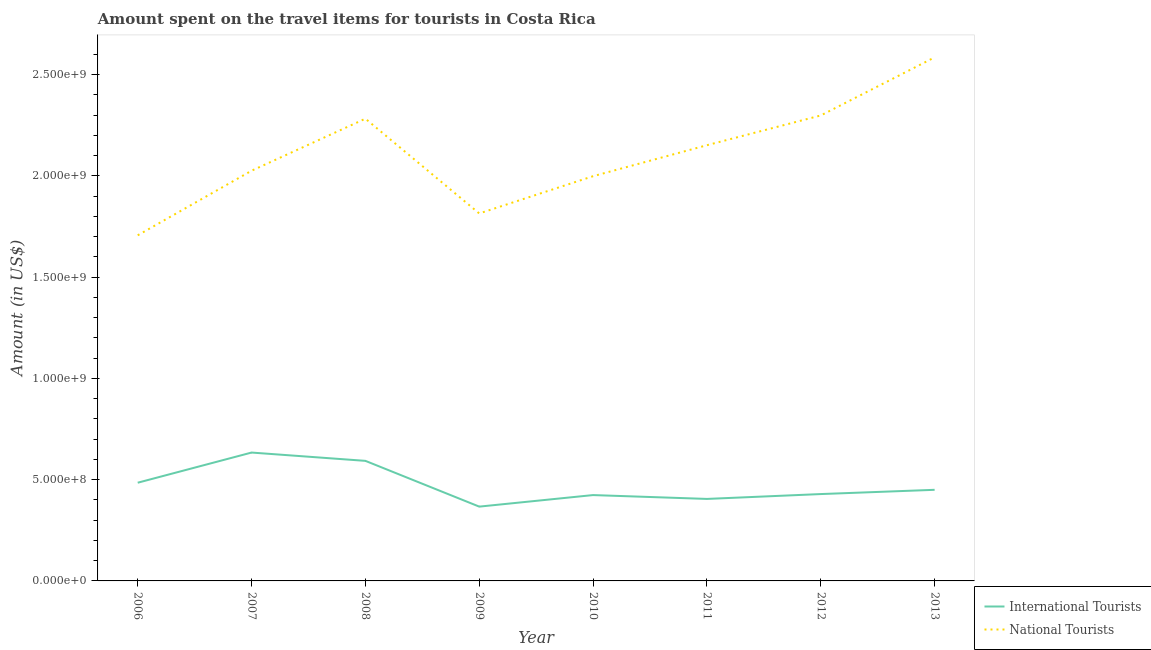How many different coloured lines are there?
Offer a very short reply. 2. Does the line corresponding to amount spent on travel items of international tourists intersect with the line corresponding to amount spent on travel items of national tourists?
Your answer should be very brief. No. What is the amount spent on travel items of international tourists in 2007?
Give a very brief answer. 6.34e+08. Across all years, what is the maximum amount spent on travel items of national tourists?
Provide a succinct answer. 2.59e+09. Across all years, what is the minimum amount spent on travel items of national tourists?
Your answer should be very brief. 1.71e+09. What is the total amount spent on travel items of international tourists in the graph?
Offer a terse response. 3.79e+09. What is the difference between the amount spent on travel items of national tourists in 2011 and that in 2013?
Your response must be concise. -4.34e+08. What is the difference between the amount spent on travel items of national tourists in 2006 and the amount spent on travel items of international tourists in 2009?
Give a very brief answer. 1.34e+09. What is the average amount spent on travel items of international tourists per year?
Your response must be concise. 4.73e+08. In the year 2012, what is the difference between the amount spent on travel items of international tourists and amount spent on travel items of national tourists?
Your response must be concise. -1.87e+09. What is the ratio of the amount spent on travel items of national tourists in 2007 to that in 2013?
Ensure brevity in your answer.  0.78. Is the amount spent on travel items of national tourists in 2008 less than that in 2010?
Make the answer very short. No. What is the difference between the highest and the second highest amount spent on travel items of international tourists?
Provide a short and direct response. 4.10e+07. What is the difference between the highest and the lowest amount spent on travel items of national tourists?
Your answer should be compact. 8.79e+08. In how many years, is the amount spent on travel items of international tourists greater than the average amount spent on travel items of international tourists taken over all years?
Your answer should be very brief. 3. Is the sum of the amount spent on travel items of national tourists in 2008 and 2012 greater than the maximum amount spent on travel items of international tourists across all years?
Offer a very short reply. Yes. Does the amount spent on travel items of international tourists monotonically increase over the years?
Your answer should be compact. No. Is the amount spent on travel items of national tourists strictly less than the amount spent on travel items of international tourists over the years?
Make the answer very short. No. How many lines are there?
Give a very brief answer. 2. How many years are there in the graph?
Offer a very short reply. 8. What is the difference between two consecutive major ticks on the Y-axis?
Your response must be concise. 5.00e+08. Does the graph contain any zero values?
Provide a succinct answer. No. Does the graph contain grids?
Your answer should be compact. No. Where does the legend appear in the graph?
Provide a short and direct response. Bottom right. What is the title of the graph?
Provide a succinct answer. Amount spent on the travel items for tourists in Costa Rica. Does "Mobile cellular" appear as one of the legend labels in the graph?
Keep it short and to the point. No. What is the label or title of the X-axis?
Make the answer very short. Year. What is the label or title of the Y-axis?
Your answer should be very brief. Amount (in US$). What is the Amount (in US$) in International Tourists in 2006?
Provide a succinct answer. 4.85e+08. What is the Amount (in US$) of National Tourists in 2006?
Ensure brevity in your answer.  1.71e+09. What is the Amount (in US$) of International Tourists in 2007?
Offer a terse response. 6.34e+08. What is the Amount (in US$) of National Tourists in 2007?
Provide a short and direct response. 2.03e+09. What is the Amount (in US$) in International Tourists in 2008?
Make the answer very short. 5.93e+08. What is the Amount (in US$) of National Tourists in 2008?
Offer a very short reply. 2.28e+09. What is the Amount (in US$) of International Tourists in 2009?
Give a very brief answer. 3.67e+08. What is the Amount (in US$) in National Tourists in 2009?
Provide a short and direct response. 1.82e+09. What is the Amount (in US$) in International Tourists in 2010?
Offer a very short reply. 4.24e+08. What is the Amount (in US$) of National Tourists in 2010?
Your answer should be very brief. 2.00e+09. What is the Amount (in US$) in International Tourists in 2011?
Give a very brief answer. 4.05e+08. What is the Amount (in US$) in National Tourists in 2011?
Offer a terse response. 2.15e+09. What is the Amount (in US$) in International Tourists in 2012?
Keep it short and to the point. 4.29e+08. What is the Amount (in US$) in National Tourists in 2012?
Provide a short and direct response. 2.30e+09. What is the Amount (in US$) of International Tourists in 2013?
Ensure brevity in your answer.  4.50e+08. What is the Amount (in US$) of National Tourists in 2013?
Ensure brevity in your answer.  2.59e+09. Across all years, what is the maximum Amount (in US$) of International Tourists?
Offer a terse response. 6.34e+08. Across all years, what is the maximum Amount (in US$) of National Tourists?
Give a very brief answer. 2.59e+09. Across all years, what is the minimum Amount (in US$) in International Tourists?
Your answer should be compact. 3.67e+08. Across all years, what is the minimum Amount (in US$) in National Tourists?
Offer a terse response. 1.71e+09. What is the total Amount (in US$) in International Tourists in the graph?
Ensure brevity in your answer.  3.79e+09. What is the total Amount (in US$) in National Tourists in the graph?
Give a very brief answer. 1.69e+1. What is the difference between the Amount (in US$) in International Tourists in 2006 and that in 2007?
Offer a very short reply. -1.49e+08. What is the difference between the Amount (in US$) in National Tourists in 2006 and that in 2007?
Give a very brief answer. -3.19e+08. What is the difference between the Amount (in US$) of International Tourists in 2006 and that in 2008?
Make the answer very short. -1.08e+08. What is the difference between the Amount (in US$) in National Tourists in 2006 and that in 2008?
Provide a short and direct response. -5.76e+08. What is the difference between the Amount (in US$) of International Tourists in 2006 and that in 2009?
Make the answer very short. 1.18e+08. What is the difference between the Amount (in US$) of National Tourists in 2006 and that in 2009?
Offer a terse response. -1.08e+08. What is the difference between the Amount (in US$) in International Tourists in 2006 and that in 2010?
Provide a succinct answer. 6.10e+07. What is the difference between the Amount (in US$) of National Tourists in 2006 and that in 2010?
Offer a very short reply. -2.92e+08. What is the difference between the Amount (in US$) in International Tourists in 2006 and that in 2011?
Keep it short and to the point. 8.00e+07. What is the difference between the Amount (in US$) of National Tourists in 2006 and that in 2011?
Your answer should be very brief. -4.45e+08. What is the difference between the Amount (in US$) of International Tourists in 2006 and that in 2012?
Keep it short and to the point. 5.60e+07. What is the difference between the Amount (in US$) in National Tourists in 2006 and that in 2012?
Give a very brief answer. -5.92e+08. What is the difference between the Amount (in US$) of International Tourists in 2006 and that in 2013?
Offer a terse response. 3.50e+07. What is the difference between the Amount (in US$) in National Tourists in 2006 and that in 2013?
Your answer should be compact. -8.79e+08. What is the difference between the Amount (in US$) of International Tourists in 2007 and that in 2008?
Your answer should be very brief. 4.10e+07. What is the difference between the Amount (in US$) in National Tourists in 2007 and that in 2008?
Ensure brevity in your answer.  -2.57e+08. What is the difference between the Amount (in US$) in International Tourists in 2007 and that in 2009?
Offer a terse response. 2.67e+08. What is the difference between the Amount (in US$) in National Tourists in 2007 and that in 2009?
Make the answer very short. 2.11e+08. What is the difference between the Amount (in US$) of International Tourists in 2007 and that in 2010?
Your answer should be compact. 2.10e+08. What is the difference between the Amount (in US$) of National Tourists in 2007 and that in 2010?
Provide a succinct answer. 2.70e+07. What is the difference between the Amount (in US$) of International Tourists in 2007 and that in 2011?
Your answer should be compact. 2.29e+08. What is the difference between the Amount (in US$) in National Tourists in 2007 and that in 2011?
Your response must be concise. -1.26e+08. What is the difference between the Amount (in US$) in International Tourists in 2007 and that in 2012?
Your answer should be very brief. 2.05e+08. What is the difference between the Amount (in US$) of National Tourists in 2007 and that in 2012?
Your answer should be very brief. -2.73e+08. What is the difference between the Amount (in US$) in International Tourists in 2007 and that in 2013?
Make the answer very short. 1.84e+08. What is the difference between the Amount (in US$) in National Tourists in 2007 and that in 2013?
Your answer should be very brief. -5.60e+08. What is the difference between the Amount (in US$) of International Tourists in 2008 and that in 2009?
Keep it short and to the point. 2.26e+08. What is the difference between the Amount (in US$) in National Tourists in 2008 and that in 2009?
Give a very brief answer. 4.68e+08. What is the difference between the Amount (in US$) of International Tourists in 2008 and that in 2010?
Provide a succinct answer. 1.69e+08. What is the difference between the Amount (in US$) in National Tourists in 2008 and that in 2010?
Give a very brief answer. 2.84e+08. What is the difference between the Amount (in US$) of International Tourists in 2008 and that in 2011?
Your response must be concise. 1.88e+08. What is the difference between the Amount (in US$) in National Tourists in 2008 and that in 2011?
Your answer should be very brief. 1.31e+08. What is the difference between the Amount (in US$) of International Tourists in 2008 and that in 2012?
Offer a very short reply. 1.64e+08. What is the difference between the Amount (in US$) in National Tourists in 2008 and that in 2012?
Ensure brevity in your answer.  -1.60e+07. What is the difference between the Amount (in US$) in International Tourists in 2008 and that in 2013?
Your answer should be very brief. 1.43e+08. What is the difference between the Amount (in US$) of National Tourists in 2008 and that in 2013?
Your response must be concise. -3.03e+08. What is the difference between the Amount (in US$) in International Tourists in 2009 and that in 2010?
Provide a short and direct response. -5.70e+07. What is the difference between the Amount (in US$) in National Tourists in 2009 and that in 2010?
Provide a succinct answer. -1.84e+08. What is the difference between the Amount (in US$) of International Tourists in 2009 and that in 2011?
Keep it short and to the point. -3.80e+07. What is the difference between the Amount (in US$) in National Tourists in 2009 and that in 2011?
Your response must be concise. -3.37e+08. What is the difference between the Amount (in US$) in International Tourists in 2009 and that in 2012?
Your response must be concise. -6.20e+07. What is the difference between the Amount (in US$) in National Tourists in 2009 and that in 2012?
Offer a very short reply. -4.84e+08. What is the difference between the Amount (in US$) in International Tourists in 2009 and that in 2013?
Ensure brevity in your answer.  -8.30e+07. What is the difference between the Amount (in US$) of National Tourists in 2009 and that in 2013?
Provide a short and direct response. -7.71e+08. What is the difference between the Amount (in US$) in International Tourists in 2010 and that in 2011?
Your response must be concise. 1.90e+07. What is the difference between the Amount (in US$) of National Tourists in 2010 and that in 2011?
Your answer should be very brief. -1.53e+08. What is the difference between the Amount (in US$) in International Tourists in 2010 and that in 2012?
Keep it short and to the point. -5.00e+06. What is the difference between the Amount (in US$) of National Tourists in 2010 and that in 2012?
Make the answer very short. -3.00e+08. What is the difference between the Amount (in US$) in International Tourists in 2010 and that in 2013?
Offer a terse response. -2.60e+07. What is the difference between the Amount (in US$) of National Tourists in 2010 and that in 2013?
Your answer should be very brief. -5.87e+08. What is the difference between the Amount (in US$) of International Tourists in 2011 and that in 2012?
Your answer should be compact. -2.40e+07. What is the difference between the Amount (in US$) in National Tourists in 2011 and that in 2012?
Make the answer very short. -1.47e+08. What is the difference between the Amount (in US$) in International Tourists in 2011 and that in 2013?
Keep it short and to the point. -4.50e+07. What is the difference between the Amount (in US$) in National Tourists in 2011 and that in 2013?
Offer a terse response. -4.34e+08. What is the difference between the Amount (in US$) in International Tourists in 2012 and that in 2013?
Your answer should be compact. -2.10e+07. What is the difference between the Amount (in US$) of National Tourists in 2012 and that in 2013?
Provide a short and direct response. -2.87e+08. What is the difference between the Amount (in US$) of International Tourists in 2006 and the Amount (in US$) of National Tourists in 2007?
Your response must be concise. -1.54e+09. What is the difference between the Amount (in US$) in International Tourists in 2006 and the Amount (in US$) in National Tourists in 2008?
Your response must be concise. -1.80e+09. What is the difference between the Amount (in US$) of International Tourists in 2006 and the Amount (in US$) of National Tourists in 2009?
Your answer should be very brief. -1.33e+09. What is the difference between the Amount (in US$) in International Tourists in 2006 and the Amount (in US$) in National Tourists in 2010?
Your answer should be compact. -1.51e+09. What is the difference between the Amount (in US$) of International Tourists in 2006 and the Amount (in US$) of National Tourists in 2011?
Provide a succinct answer. -1.67e+09. What is the difference between the Amount (in US$) in International Tourists in 2006 and the Amount (in US$) in National Tourists in 2012?
Give a very brief answer. -1.81e+09. What is the difference between the Amount (in US$) of International Tourists in 2006 and the Amount (in US$) of National Tourists in 2013?
Your answer should be very brief. -2.10e+09. What is the difference between the Amount (in US$) in International Tourists in 2007 and the Amount (in US$) in National Tourists in 2008?
Provide a short and direct response. -1.65e+09. What is the difference between the Amount (in US$) of International Tourists in 2007 and the Amount (in US$) of National Tourists in 2009?
Your answer should be compact. -1.18e+09. What is the difference between the Amount (in US$) in International Tourists in 2007 and the Amount (in US$) in National Tourists in 2010?
Offer a very short reply. -1.36e+09. What is the difference between the Amount (in US$) of International Tourists in 2007 and the Amount (in US$) of National Tourists in 2011?
Keep it short and to the point. -1.52e+09. What is the difference between the Amount (in US$) in International Tourists in 2007 and the Amount (in US$) in National Tourists in 2012?
Your answer should be very brief. -1.66e+09. What is the difference between the Amount (in US$) in International Tourists in 2007 and the Amount (in US$) in National Tourists in 2013?
Provide a short and direct response. -1.95e+09. What is the difference between the Amount (in US$) of International Tourists in 2008 and the Amount (in US$) of National Tourists in 2009?
Provide a short and direct response. -1.22e+09. What is the difference between the Amount (in US$) of International Tourists in 2008 and the Amount (in US$) of National Tourists in 2010?
Your answer should be compact. -1.41e+09. What is the difference between the Amount (in US$) of International Tourists in 2008 and the Amount (in US$) of National Tourists in 2011?
Offer a very short reply. -1.56e+09. What is the difference between the Amount (in US$) of International Tourists in 2008 and the Amount (in US$) of National Tourists in 2012?
Make the answer very short. -1.71e+09. What is the difference between the Amount (in US$) of International Tourists in 2008 and the Amount (in US$) of National Tourists in 2013?
Ensure brevity in your answer.  -1.99e+09. What is the difference between the Amount (in US$) of International Tourists in 2009 and the Amount (in US$) of National Tourists in 2010?
Provide a succinct answer. -1.63e+09. What is the difference between the Amount (in US$) in International Tourists in 2009 and the Amount (in US$) in National Tourists in 2011?
Your answer should be very brief. -1.78e+09. What is the difference between the Amount (in US$) in International Tourists in 2009 and the Amount (in US$) in National Tourists in 2012?
Offer a very short reply. -1.93e+09. What is the difference between the Amount (in US$) of International Tourists in 2009 and the Amount (in US$) of National Tourists in 2013?
Provide a succinct answer. -2.22e+09. What is the difference between the Amount (in US$) of International Tourists in 2010 and the Amount (in US$) of National Tourists in 2011?
Provide a short and direct response. -1.73e+09. What is the difference between the Amount (in US$) of International Tourists in 2010 and the Amount (in US$) of National Tourists in 2012?
Make the answer very short. -1.88e+09. What is the difference between the Amount (in US$) in International Tourists in 2010 and the Amount (in US$) in National Tourists in 2013?
Your answer should be very brief. -2.16e+09. What is the difference between the Amount (in US$) of International Tourists in 2011 and the Amount (in US$) of National Tourists in 2012?
Make the answer very short. -1.89e+09. What is the difference between the Amount (in US$) in International Tourists in 2011 and the Amount (in US$) in National Tourists in 2013?
Keep it short and to the point. -2.18e+09. What is the difference between the Amount (in US$) in International Tourists in 2012 and the Amount (in US$) in National Tourists in 2013?
Ensure brevity in your answer.  -2.16e+09. What is the average Amount (in US$) in International Tourists per year?
Your response must be concise. 4.73e+08. What is the average Amount (in US$) in National Tourists per year?
Provide a succinct answer. 2.11e+09. In the year 2006, what is the difference between the Amount (in US$) in International Tourists and Amount (in US$) in National Tourists?
Your response must be concise. -1.22e+09. In the year 2007, what is the difference between the Amount (in US$) of International Tourists and Amount (in US$) of National Tourists?
Your answer should be compact. -1.39e+09. In the year 2008, what is the difference between the Amount (in US$) in International Tourists and Amount (in US$) in National Tourists?
Provide a short and direct response. -1.69e+09. In the year 2009, what is the difference between the Amount (in US$) of International Tourists and Amount (in US$) of National Tourists?
Keep it short and to the point. -1.45e+09. In the year 2010, what is the difference between the Amount (in US$) of International Tourists and Amount (in US$) of National Tourists?
Provide a succinct answer. -1.58e+09. In the year 2011, what is the difference between the Amount (in US$) of International Tourists and Amount (in US$) of National Tourists?
Keep it short and to the point. -1.75e+09. In the year 2012, what is the difference between the Amount (in US$) of International Tourists and Amount (in US$) of National Tourists?
Ensure brevity in your answer.  -1.87e+09. In the year 2013, what is the difference between the Amount (in US$) in International Tourists and Amount (in US$) in National Tourists?
Keep it short and to the point. -2.14e+09. What is the ratio of the Amount (in US$) of International Tourists in 2006 to that in 2007?
Offer a terse response. 0.77. What is the ratio of the Amount (in US$) of National Tourists in 2006 to that in 2007?
Make the answer very short. 0.84. What is the ratio of the Amount (in US$) of International Tourists in 2006 to that in 2008?
Keep it short and to the point. 0.82. What is the ratio of the Amount (in US$) of National Tourists in 2006 to that in 2008?
Keep it short and to the point. 0.75. What is the ratio of the Amount (in US$) in International Tourists in 2006 to that in 2009?
Make the answer very short. 1.32. What is the ratio of the Amount (in US$) of National Tourists in 2006 to that in 2009?
Give a very brief answer. 0.94. What is the ratio of the Amount (in US$) of International Tourists in 2006 to that in 2010?
Keep it short and to the point. 1.14. What is the ratio of the Amount (in US$) in National Tourists in 2006 to that in 2010?
Make the answer very short. 0.85. What is the ratio of the Amount (in US$) in International Tourists in 2006 to that in 2011?
Give a very brief answer. 1.2. What is the ratio of the Amount (in US$) of National Tourists in 2006 to that in 2011?
Offer a terse response. 0.79. What is the ratio of the Amount (in US$) of International Tourists in 2006 to that in 2012?
Your answer should be compact. 1.13. What is the ratio of the Amount (in US$) of National Tourists in 2006 to that in 2012?
Give a very brief answer. 0.74. What is the ratio of the Amount (in US$) of International Tourists in 2006 to that in 2013?
Offer a very short reply. 1.08. What is the ratio of the Amount (in US$) in National Tourists in 2006 to that in 2013?
Ensure brevity in your answer.  0.66. What is the ratio of the Amount (in US$) in International Tourists in 2007 to that in 2008?
Keep it short and to the point. 1.07. What is the ratio of the Amount (in US$) of National Tourists in 2007 to that in 2008?
Your response must be concise. 0.89. What is the ratio of the Amount (in US$) of International Tourists in 2007 to that in 2009?
Ensure brevity in your answer.  1.73. What is the ratio of the Amount (in US$) in National Tourists in 2007 to that in 2009?
Provide a succinct answer. 1.12. What is the ratio of the Amount (in US$) of International Tourists in 2007 to that in 2010?
Your answer should be compact. 1.5. What is the ratio of the Amount (in US$) of National Tourists in 2007 to that in 2010?
Keep it short and to the point. 1.01. What is the ratio of the Amount (in US$) in International Tourists in 2007 to that in 2011?
Give a very brief answer. 1.57. What is the ratio of the Amount (in US$) of National Tourists in 2007 to that in 2011?
Make the answer very short. 0.94. What is the ratio of the Amount (in US$) in International Tourists in 2007 to that in 2012?
Offer a very short reply. 1.48. What is the ratio of the Amount (in US$) of National Tourists in 2007 to that in 2012?
Your response must be concise. 0.88. What is the ratio of the Amount (in US$) of International Tourists in 2007 to that in 2013?
Your answer should be very brief. 1.41. What is the ratio of the Amount (in US$) in National Tourists in 2007 to that in 2013?
Your response must be concise. 0.78. What is the ratio of the Amount (in US$) of International Tourists in 2008 to that in 2009?
Offer a very short reply. 1.62. What is the ratio of the Amount (in US$) in National Tourists in 2008 to that in 2009?
Make the answer very short. 1.26. What is the ratio of the Amount (in US$) in International Tourists in 2008 to that in 2010?
Provide a succinct answer. 1.4. What is the ratio of the Amount (in US$) in National Tourists in 2008 to that in 2010?
Offer a terse response. 1.14. What is the ratio of the Amount (in US$) of International Tourists in 2008 to that in 2011?
Your answer should be very brief. 1.46. What is the ratio of the Amount (in US$) in National Tourists in 2008 to that in 2011?
Give a very brief answer. 1.06. What is the ratio of the Amount (in US$) in International Tourists in 2008 to that in 2012?
Provide a succinct answer. 1.38. What is the ratio of the Amount (in US$) of International Tourists in 2008 to that in 2013?
Offer a very short reply. 1.32. What is the ratio of the Amount (in US$) of National Tourists in 2008 to that in 2013?
Provide a short and direct response. 0.88. What is the ratio of the Amount (in US$) in International Tourists in 2009 to that in 2010?
Offer a very short reply. 0.87. What is the ratio of the Amount (in US$) in National Tourists in 2009 to that in 2010?
Provide a short and direct response. 0.91. What is the ratio of the Amount (in US$) in International Tourists in 2009 to that in 2011?
Ensure brevity in your answer.  0.91. What is the ratio of the Amount (in US$) in National Tourists in 2009 to that in 2011?
Make the answer very short. 0.84. What is the ratio of the Amount (in US$) in International Tourists in 2009 to that in 2012?
Keep it short and to the point. 0.86. What is the ratio of the Amount (in US$) of National Tourists in 2009 to that in 2012?
Offer a very short reply. 0.79. What is the ratio of the Amount (in US$) in International Tourists in 2009 to that in 2013?
Ensure brevity in your answer.  0.82. What is the ratio of the Amount (in US$) of National Tourists in 2009 to that in 2013?
Your answer should be very brief. 0.7. What is the ratio of the Amount (in US$) of International Tourists in 2010 to that in 2011?
Your answer should be compact. 1.05. What is the ratio of the Amount (in US$) of National Tourists in 2010 to that in 2011?
Keep it short and to the point. 0.93. What is the ratio of the Amount (in US$) in International Tourists in 2010 to that in 2012?
Your answer should be compact. 0.99. What is the ratio of the Amount (in US$) of National Tourists in 2010 to that in 2012?
Make the answer very short. 0.87. What is the ratio of the Amount (in US$) of International Tourists in 2010 to that in 2013?
Offer a terse response. 0.94. What is the ratio of the Amount (in US$) of National Tourists in 2010 to that in 2013?
Make the answer very short. 0.77. What is the ratio of the Amount (in US$) in International Tourists in 2011 to that in 2012?
Ensure brevity in your answer.  0.94. What is the ratio of the Amount (in US$) of National Tourists in 2011 to that in 2012?
Make the answer very short. 0.94. What is the ratio of the Amount (in US$) of National Tourists in 2011 to that in 2013?
Provide a short and direct response. 0.83. What is the ratio of the Amount (in US$) of International Tourists in 2012 to that in 2013?
Provide a succinct answer. 0.95. What is the ratio of the Amount (in US$) of National Tourists in 2012 to that in 2013?
Your answer should be compact. 0.89. What is the difference between the highest and the second highest Amount (in US$) in International Tourists?
Keep it short and to the point. 4.10e+07. What is the difference between the highest and the second highest Amount (in US$) in National Tourists?
Your answer should be compact. 2.87e+08. What is the difference between the highest and the lowest Amount (in US$) of International Tourists?
Offer a terse response. 2.67e+08. What is the difference between the highest and the lowest Amount (in US$) in National Tourists?
Provide a succinct answer. 8.79e+08. 